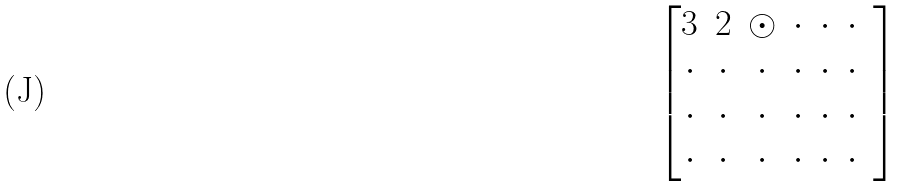<formula> <loc_0><loc_0><loc_500><loc_500>\begin{bmatrix} 3 & 2 & \odot & \cdot & \cdot & \cdot & \\ \cdot & \cdot & \cdot & \cdot & \cdot & \cdot & \\ \cdot & \cdot & \cdot & \cdot & \cdot & \cdot & \\ \cdot & \cdot & \cdot & \cdot & \cdot & \cdot & \end{bmatrix}</formula> 